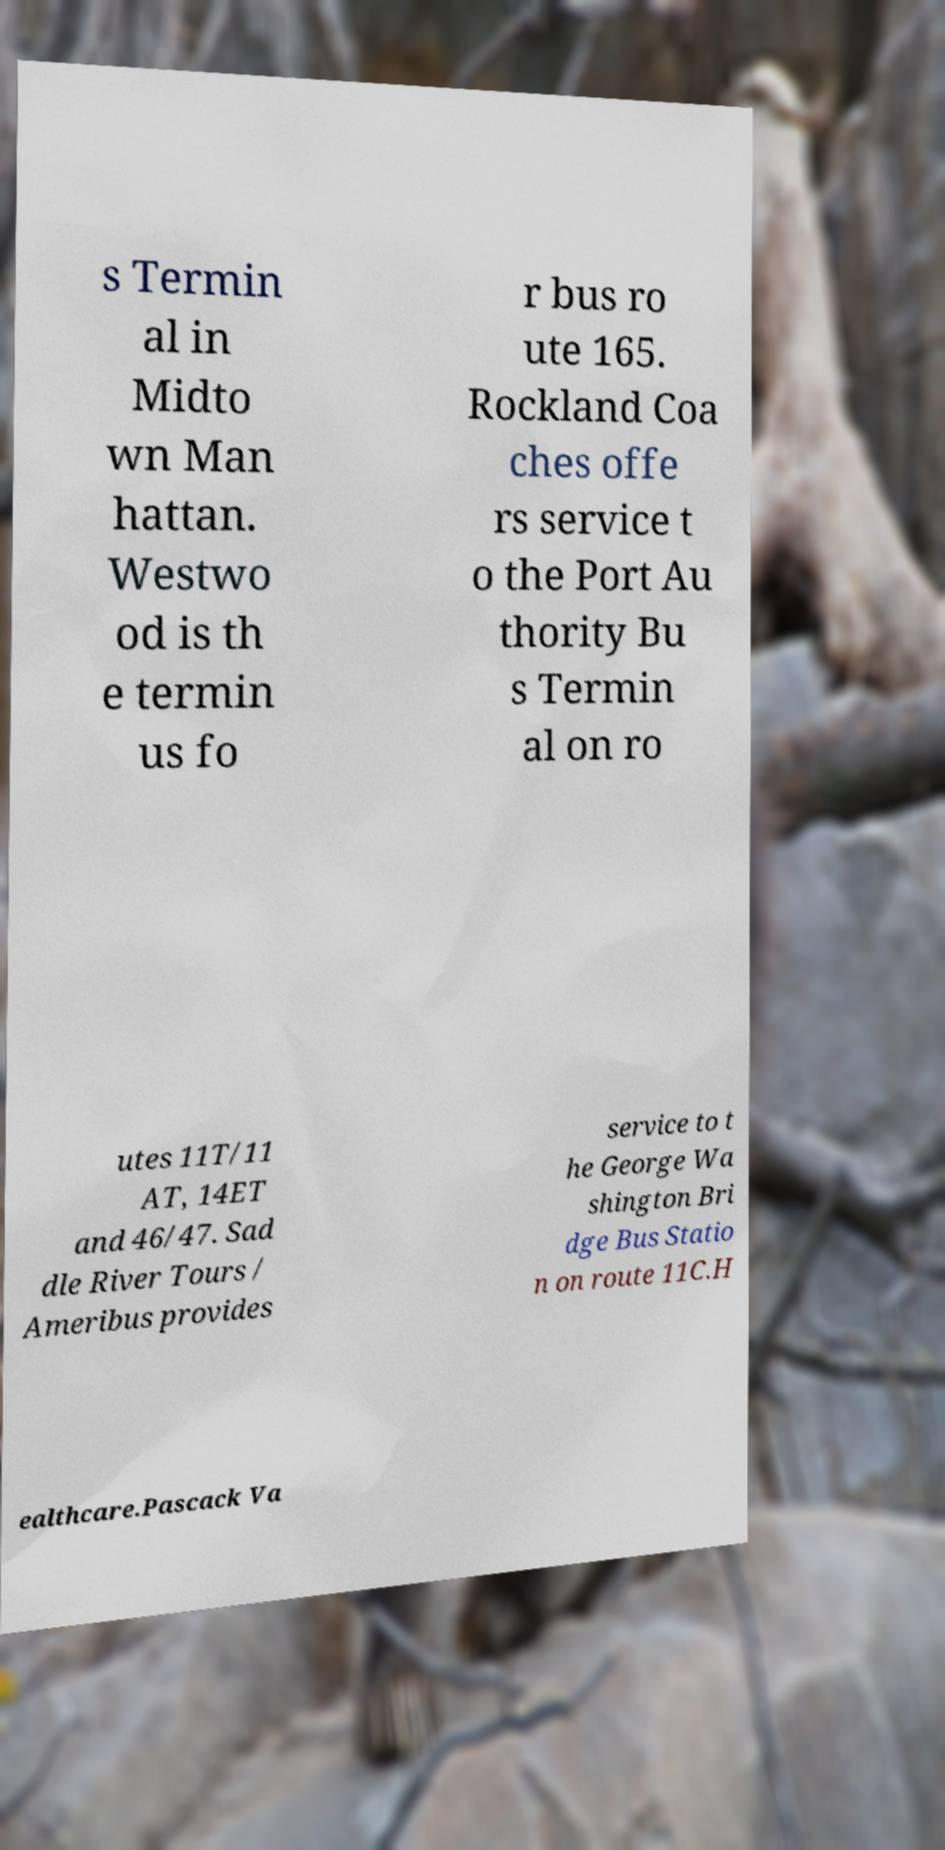Please read and relay the text visible in this image. What does it say? s Termin al in Midto wn Man hattan. Westwo od is th e termin us fo r bus ro ute 165. Rockland Coa ches offe rs service t o the Port Au thority Bu s Termin al on ro utes 11T/11 AT, 14ET and 46/47. Sad dle River Tours / Ameribus provides service to t he George Wa shington Bri dge Bus Statio n on route 11C.H ealthcare.Pascack Va 